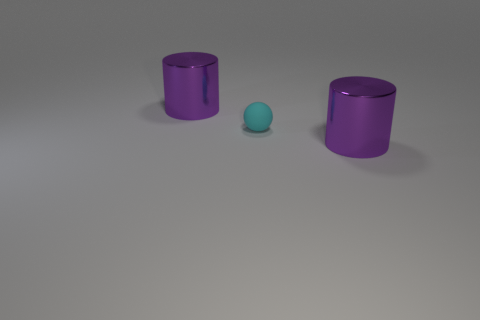Are there any other cyan balls of the same size as the cyan rubber ball?
Offer a very short reply. No. There is a large cylinder in front of the small sphere; what material is it?
Keep it short and to the point. Metal. How many metallic objects are either cyan objects or green things?
Your answer should be very brief. 0. How many objects are purple metallic objects behind the tiny cyan rubber thing or large purple shiny cylinders that are to the left of the matte object?
Offer a very short reply. 1. What number of other objects are the same material as the small sphere?
Your response must be concise. 0. What number of purple objects are either metallic things or small things?
Offer a very short reply. 2. There is a small matte ball; is it the same color as the big cylinder to the right of the tiny cyan sphere?
Provide a short and direct response. No. Are there fewer tiny cyan balls than big objects?
Keep it short and to the point. Yes. How many rubber things are in front of the big purple cylinder in front of the big thing left of the tiny cyan thing?
Provide a short and direct response. 0. There is a thing that is to the left of the small cyan thing; how big is it?
Provide a succinct answer. Large. 